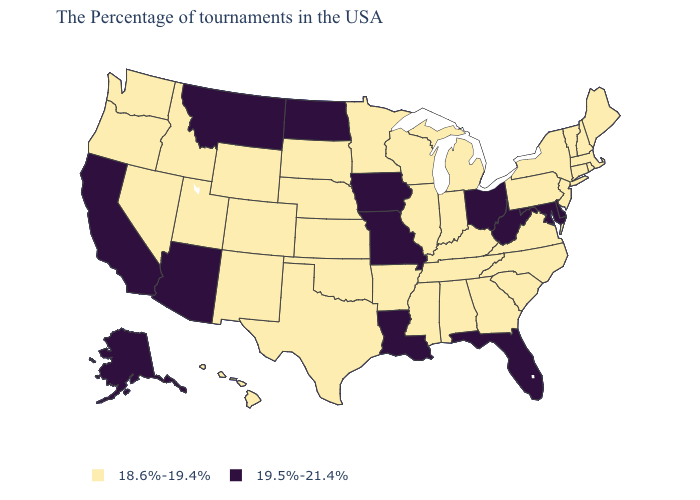Does Mississippi have the same value as Delaware?
Write a very short answer. No. What is the highest value in the MidWest ?
Keep it brief. 19.5%-21.4%. Does the first symbol in the legend represent the smallest category?
Concise answer only. Yes. Among the states that border Nebraska , does South Dakota have the lowest value?
Answer briefly. Yes. Does New Mexico have a lower value than Missouri?
Short answer required. Yes. How many symbols are there in the legend?
Concise answer only. 2. Name the states that have a value in the range 18.6%-19.4%?
Give a very brief answer. Maine, Massachusetts, Rhode Island, New Hampshire, Vermont, Connecticut, New York, New Jersey, Pennsylvania, Virginia, North Carolina, South Carolina, Georgia, Michigan, Kentucky, Indiana, Alabama, Tennessee, Wisconsin, Illinois, Mississippi, Arkansas, Minnesota, Kansas, Nebraska, Oklahoma, Texas, South Dakota, Wyoming, Colorado, New Mexico, Utah, Idaho, Nevada, Washington, Oregon, Hawaii. Name the states that have a value in the range 18.6%-19.4%?
Concise answer only. Maine, Massachusetts, Rhode Island, New Hampshire, Vermont, Connecticut, New York, New Jersey, Pennsylvania, Virginia, North Carolina, South Carolina, Georgia, Michigan, Kentucky, Indiana, Alabama, Tennessee, Wisconsin, Illinois, Mississippi, Arkansas, Minnesota, Kansas, Nebraska, Oklahoma, Texas, South Dakota, Wyoming, Colorado, New Mexico, Utah, Idaho, Nevada, Washington, Oregon, Hawaii. Does Georgia have a higher value than Virginia?
Be succinct. No. Does the first symbol in the legend represent the smallest category?
Short answer required. Yes. How many symbols are there in the legend?
Keep it brief. 2. What is the value of Iowa?
Give a very brief answer. 19.5%-21.4%. What is the lowest value in the USA?
Short answer required. 18.6%-19.4%. Name the states that have a value in the range 19.5%-21.4%?
Answer briefly. Delaware, Maryland, West Virginia, Ohio, Florida, Louisiana, Missouri, Iowa, North Dakota, Montana, Arizona, California, Alaska. What is the highest value in the South ?
Keep it brief. 19.5%-21.4%. 